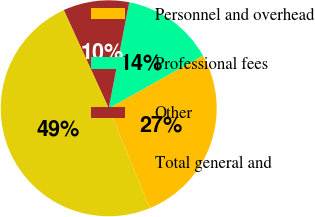Convert chart. <chart><loc_0><loc_0><loc_500><loc_500><pie_chart><fcel>Personnel and overhead<fcel>Professional fees<fcel>Other<fcel>Total general and<nl><fcel>26.91%<fcel>13.83%<fcel>9.88%<fcel>49.39%<nl></chart> 